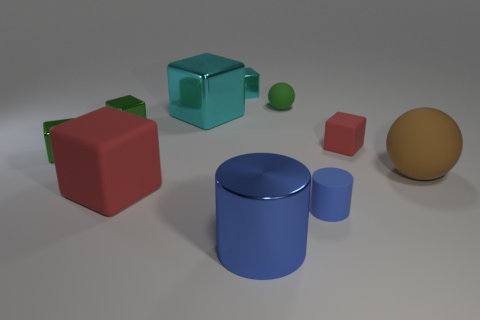What is the shape of the thing that is the same color as the large matte block?
Offer a very short reply. Cube. There is a tiny cube that is both right of the large red thing and in front of the small cyan metal cube; what material is it made of?
Provide a succinct answer. Rubber. There is a red matte block on the left side of the blue rubber thing; is its size the same as the big blue object?
Your answer should be compact. Yes. Is the color of the small matte block the same as the large rubber block?
Provide a short and direct response. Yes. How many objects are both on the right side of the big blue metallic thing and behind the large red block?
Make the answer very short. 3. There is a tiny green shiny block behind the red rubber cube that is behind the large matte ball; how many small cyan metallic cubes are right of it?
Provide a succinct answer. 1. What size is the matte object that is the same color as the shiny cylinder?
Provide a succinct answer. Small. There is a large blue thing; what shape is it?
Your answer should be compact. Cylinder. What number of tiny blue objects are made of the same material as the small green ball?
Offer a very short reply. 1. The tiny cylinder that is the same material as the large brown ball is what color?
Ensure brevity in your answer.  Blue. 